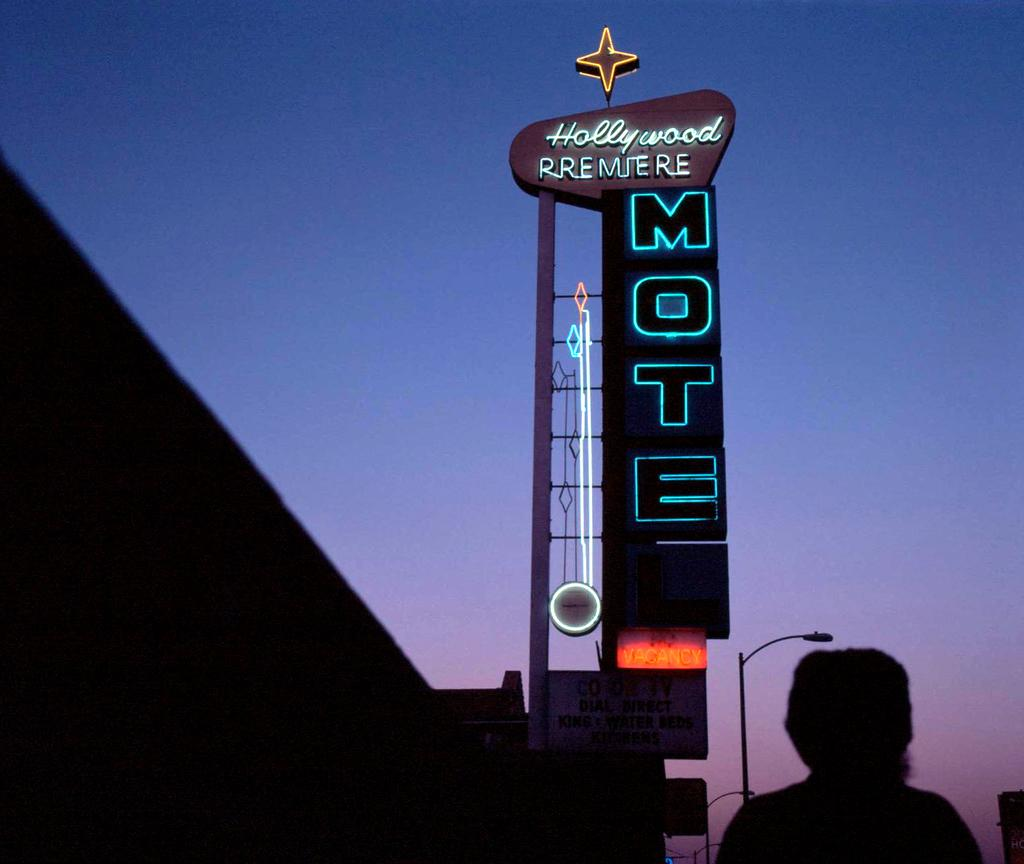What is the main subject of the image? There is a person in the image. What is located beside the person? There is a neon sign beside the person. What type of structure can be seen in the image? There is a building in the image. What other object is present in the image? There is a lamppost in the image. What type of sugar is being used for the dinner in the image? There is no dinner or sugar present in the image. Can you tell me how many bees are buzzing around the person in the image? There are no bees present in the image. 